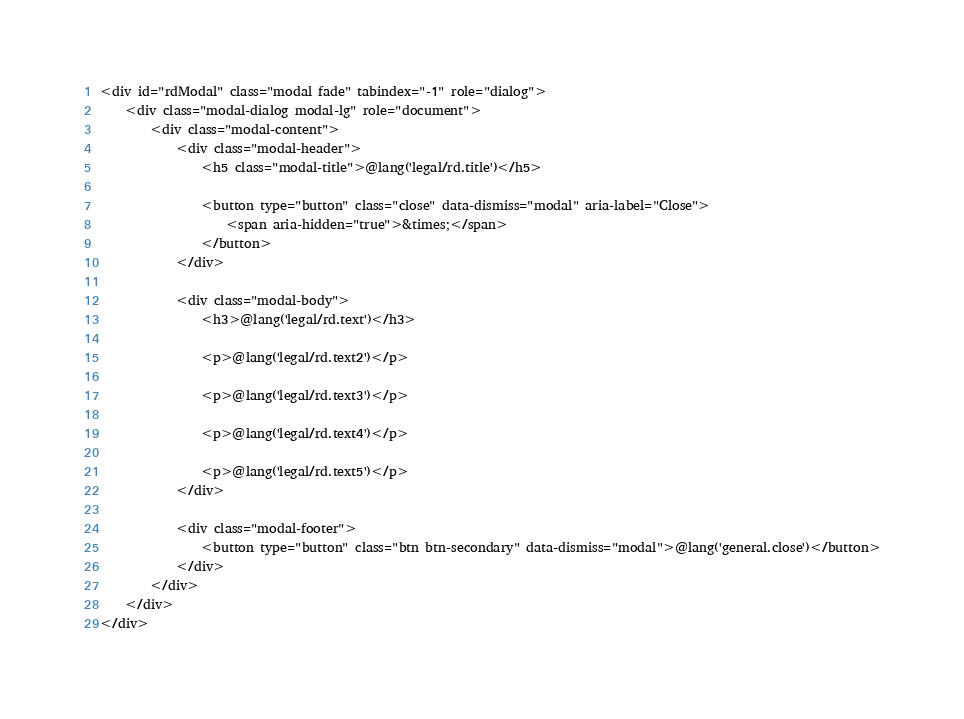<code> <loc_0><loc_0><loc_500><loc_500><_PHP_><div id="rdModal" class="modal fade" tabindex="-1" role="dialog">
    <div class="modal-dialog modal-lg" role="document">
        <div class="modal-content">
            <div class="modal-header">
                <h5 class="modal-title">@lang('legal/rd.title')</h5>

                <button type="button" class="close" data-dismiss="modal" aria-label="Close">
                    <span aria-hidden="true">&times;</span>
                </button>
            </div>

            <div class="modal-body">
                <h3>@lang('legal/rd.text')</h3>

                <p>@lang('legal/rd.text2')</p>

                <p>@lang('legal/rd.text3')</p>

                <p>@lang('legal/rd.text4')</p>

                <p>@lang('legal/rd.text5')</p>
            </div>

            <div class="modal-footer">
                <button type="button" class="btn btn-secondary" data-dismiss="modal">@lang('general.close')</button>
            </div>
        </div>
    </div>
</div></code> 